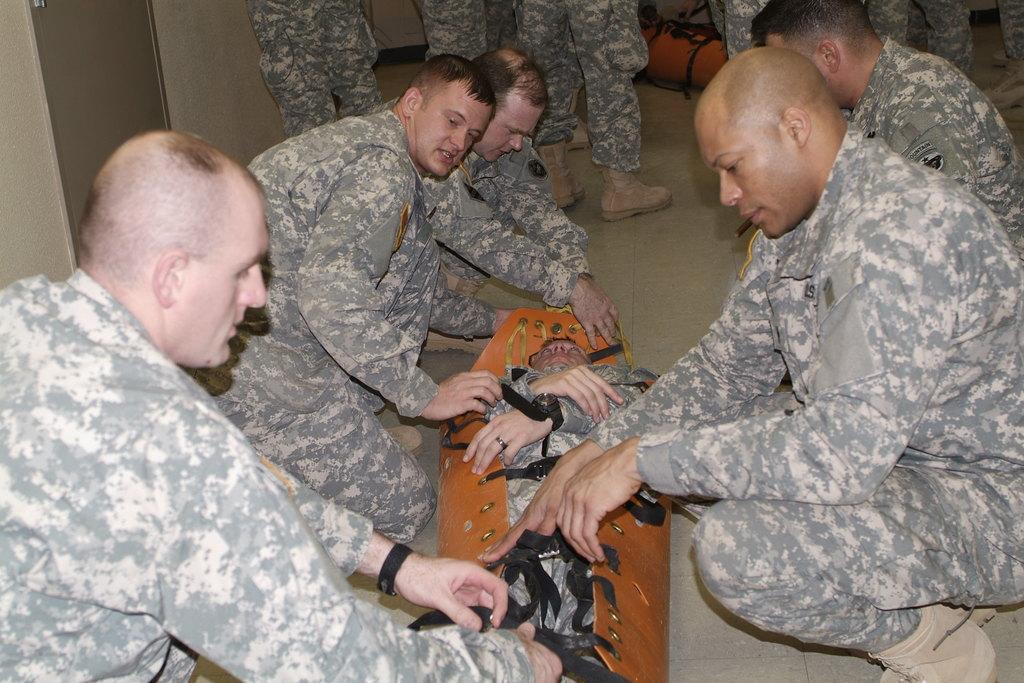Please provide a concise description of this image. In this picture we can see some military soldiers sitting on the ground and covering the dead body of a military soldier in the brown leather cloth. 